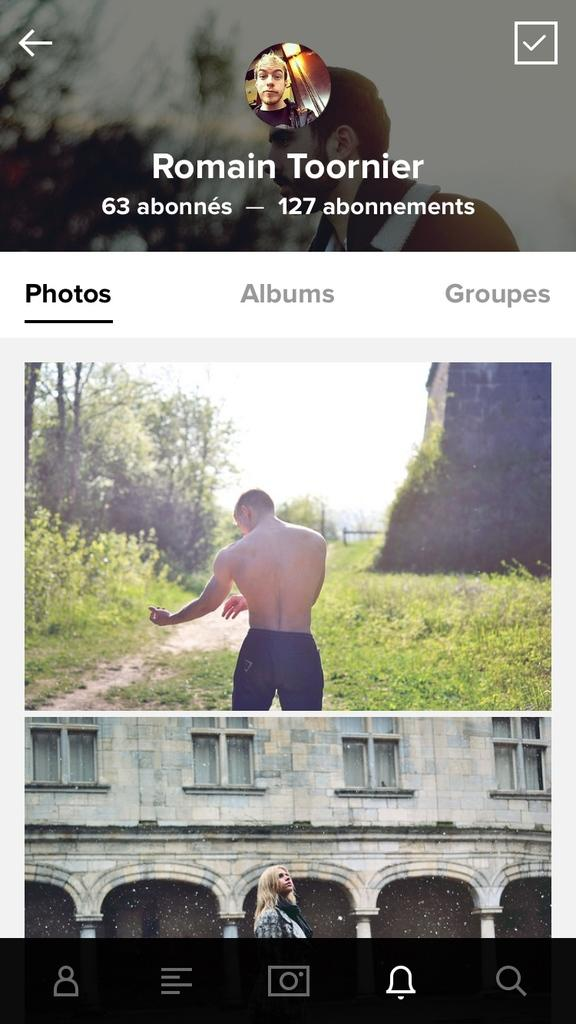What can be seen in the screenshot? There are people, a building, grass, and sky visible in the screenshot. What else is present in the screenshot besides the people and the building? There is text present in the screenshot. How many leaves are on the yam in the screenshot? There is no yam or leaf present in the screenshot. What is the title of the screenshot? The screenshot does not have a title; it is an image with various elements, including people, a building, grass, sky, and text. 